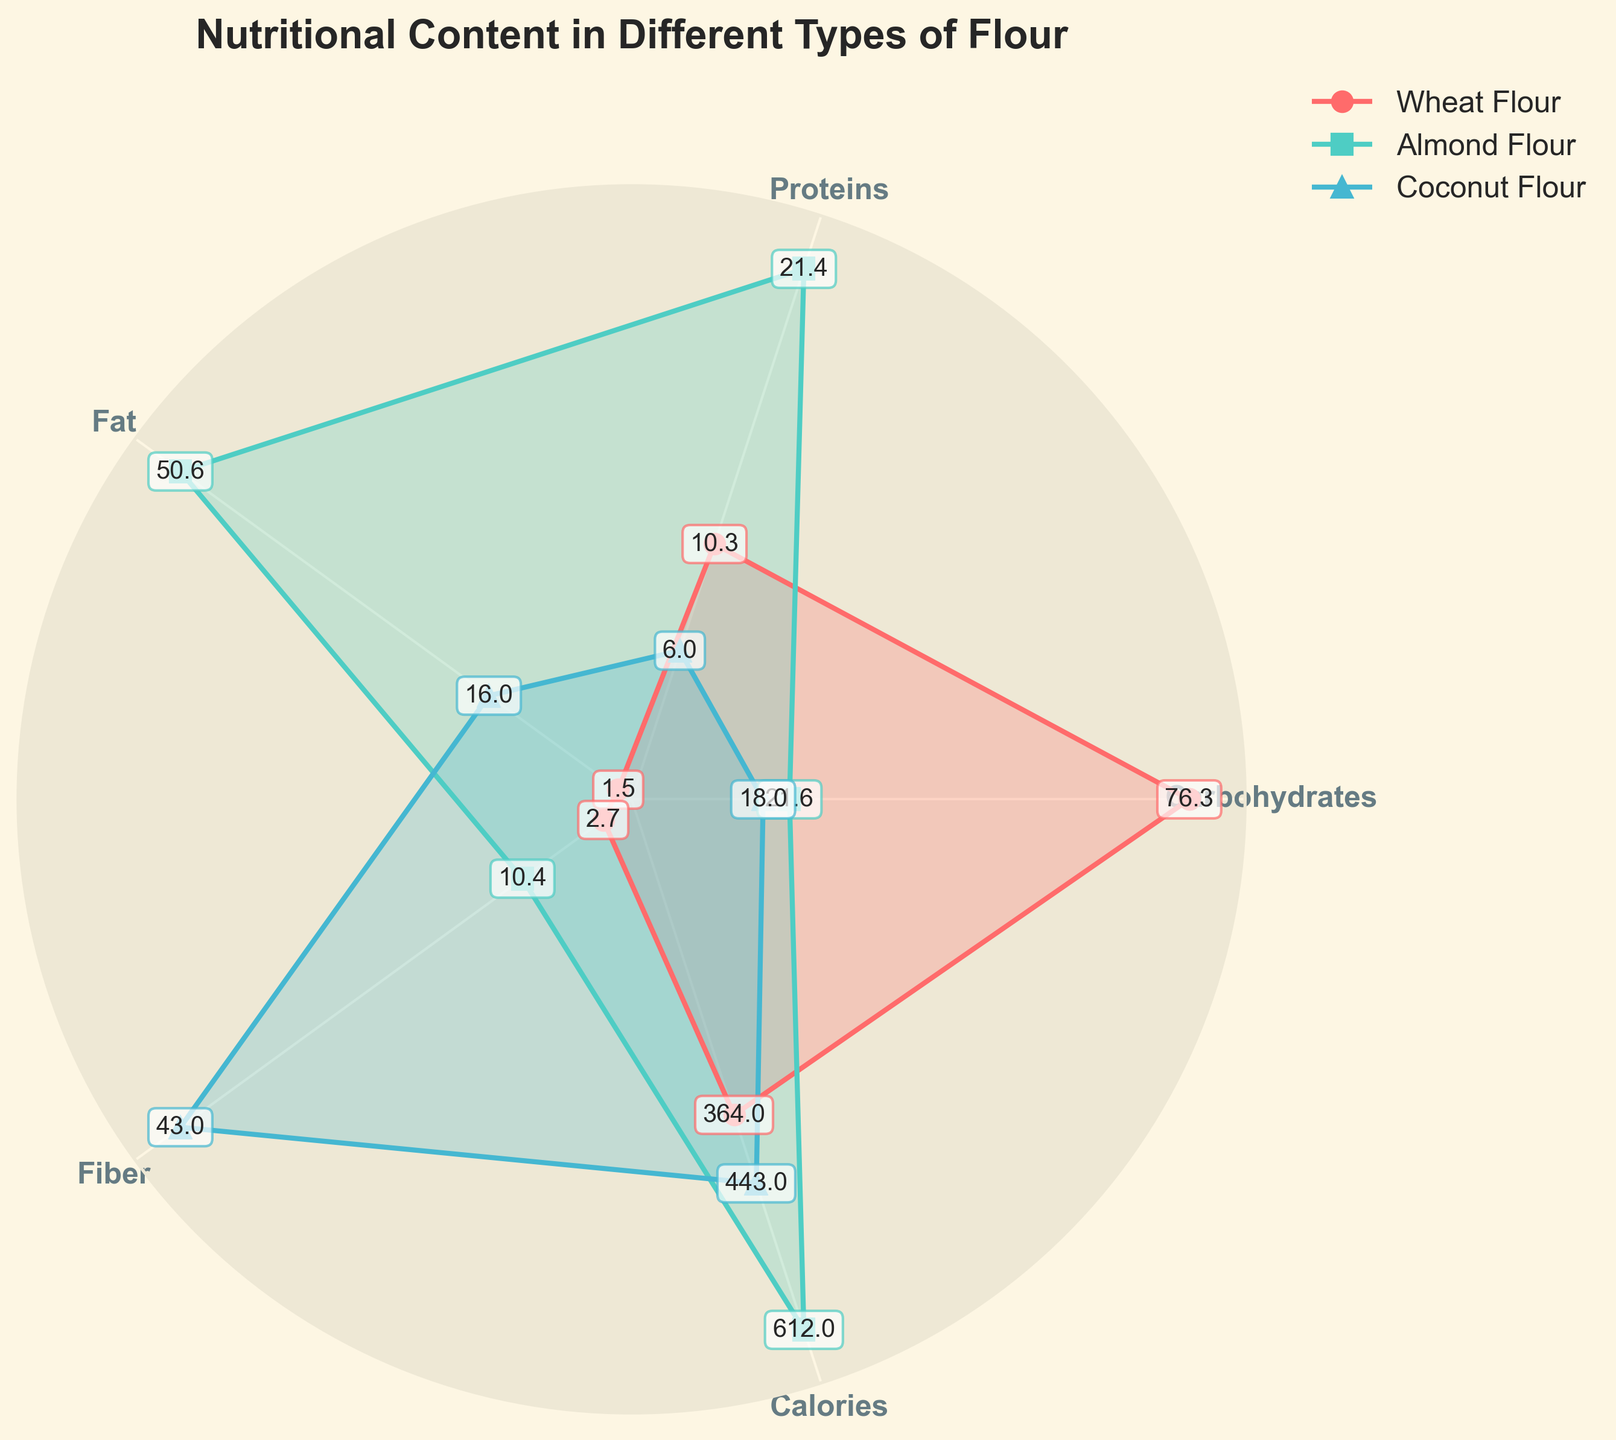What's the title of the chart? The title is usually placed at the top of the figure. It helps to provide an overview of what the chart is about.
Answer: Nutritional Content in Different Types of Flour How many types of flour are compared in the chart? By looking at the legend and the number of lines on the radar chart, you can identify the number of categories.
Answer: Three (Wheat Flour, Almond Flour, Coconut Flour) Which flour type has the highest value for Fiber (g/100g)? Look at the Fiber axis and find the flour whose line extends the furthest.
Answer: Coconut Flour What's the average value of Calories (kcal/100g) for all three types of flour? Add the calorie values for each flour (364 + 612 + 443) and divide by the number of flour types (3).
Answer: (364 + 612 + 443) / 3 = 473 Which type of flour has the lowest Carbohydrates (g/100g) content? Compare the carbohydrate values on the corresponding axis for each type of flour.
Answer: Coconut Flour What is the difference in Protein (g/100g) content between Almond Flour and Coconut Flour? Subtract the protein value of Coconut Flour from that of Almond Flour (21.4 - 6.0).
Answer: 15.4 Rank the flours based on their Fat (g/100g) content, from highest to lowest. Compare the fat values for each flour and sort them accordingly.
Answer: Almond Flour, Coconut Flour, Wheat Flour How much higher is the Calories (kcal/100g) content of Almond Flour compared to Wheat Flour? Subtract the calorie value of Wheat Flour from that of Almond Flour (612 - 364).
Answer: 248 Which flour type shows the most balanced nutritional composition across the categories? Check for the flour whose values are closest to each other across most categories, looking for small variations.
Answer: Wheat Flour Based on the chart, which nutrient is the most prominent in Coconut Flour? Identify the nutrient axis where the Coconut Flour's line extends the furthest.
Answer: Fiber 